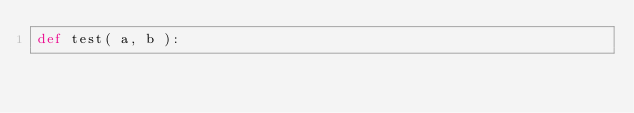<code> <loc_0><loc_0><loc_500><loc_500><_Python_>def test( a, b ):</code> 